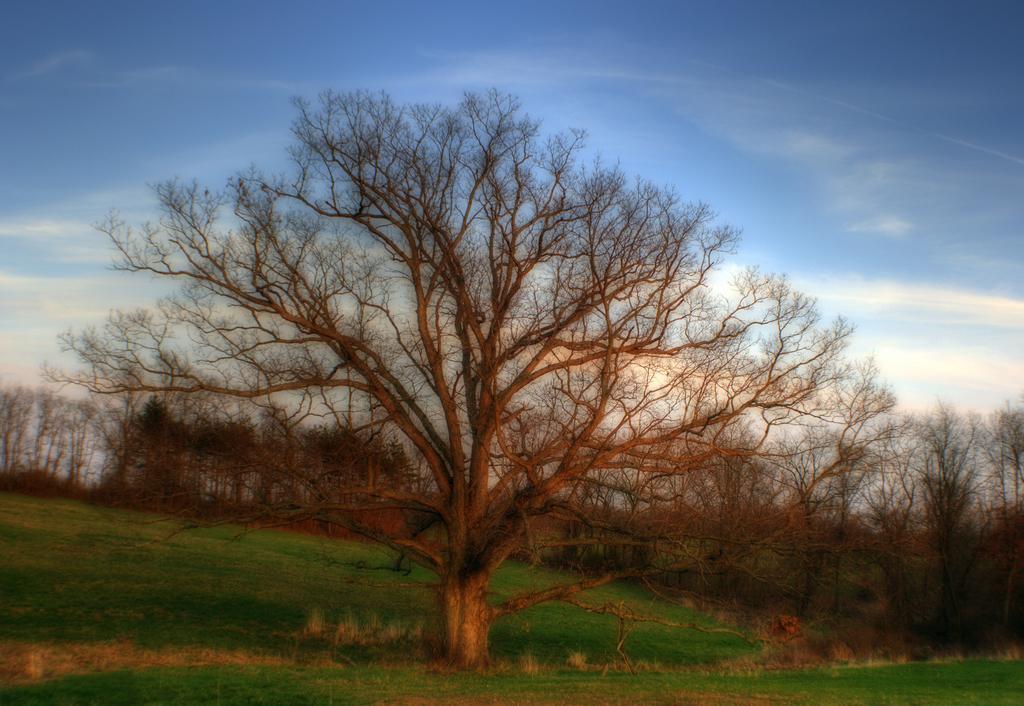Please provide a concise description of this image. In this image there is grassland, in the background there are trees and the sky. 